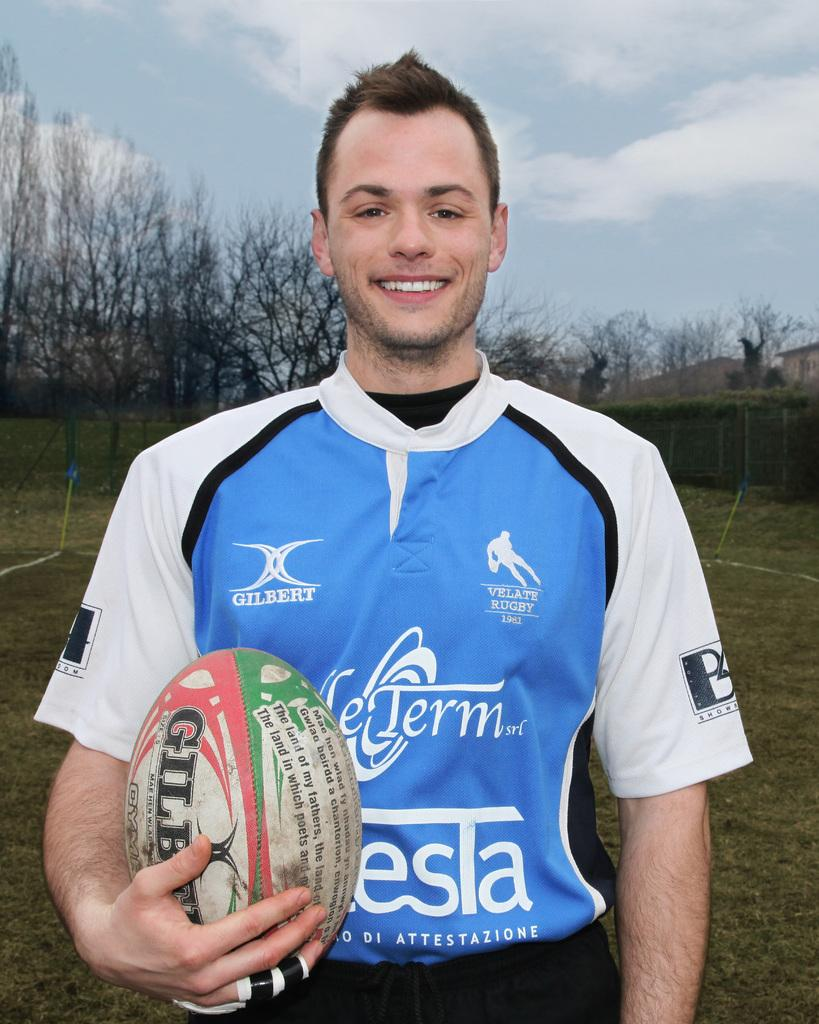What is the man in the image doing? The man is standing in the image and holding a ball. Where is the man located in the image? The man is at the bottom of the image. What can be seen in the background of the image? There are trees in the background of the image. What is visible at the top of the image? The sky is visible at the top of the image. What type of toothpaste is the man using in the image? There is no toothpaste present in the image; the man is holding a ball and standing at the bottom of the image. 